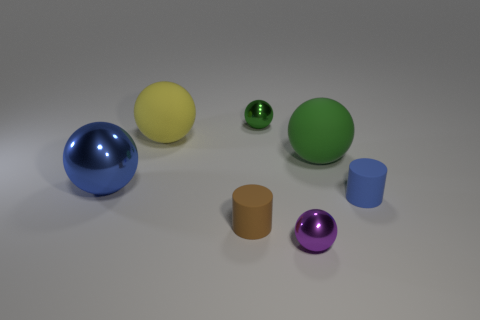There is another thing that is the same color as the big metallic thing; what is it made of?
Provide a succinct answer. Rubber. Are there more big rubber balls in front of the large green rubber object than matte things right of the tiny blue cylinder?
Your answer should be compact. No. What is the material of the big yellow thing that is the same shape as the large green thing?
Ensure brevity in your answer.  Rubber. Is there anything else that is the same size as the yellow rubber thing?
Your answer should be compact. Yes. There is a tiny shiny sphere in front of the small blue cylinder; is it the same color as the small matte object that is in front of the tiny blue matte cylinder?
Provide a short and direct response. No. What is the shape of the tiny brown object?
Offer a terse response. Cylinder. Is the number of tiny purple metallic balls behind the big blue thing greater than the number of rubber objects?
Offer a very short reply. No. There is a blue thing on the right side of the large yellow rubber ball; what shape is it?
Offer a terse response. Cylinder. How many other things are the same shape as the green metal object?
Make the answer very short. 4. Does the sphere that is in front of the tiny brown matte cylinder have the same material as the small brown cylinder?
Offer a terse response. No. 